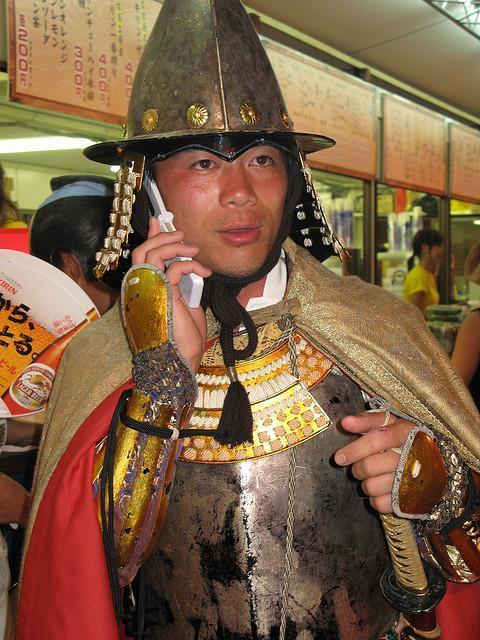How many people are visible?
Give a very brief answer. 4. How many kites in the sky?
Give a very brief answer. 0. 